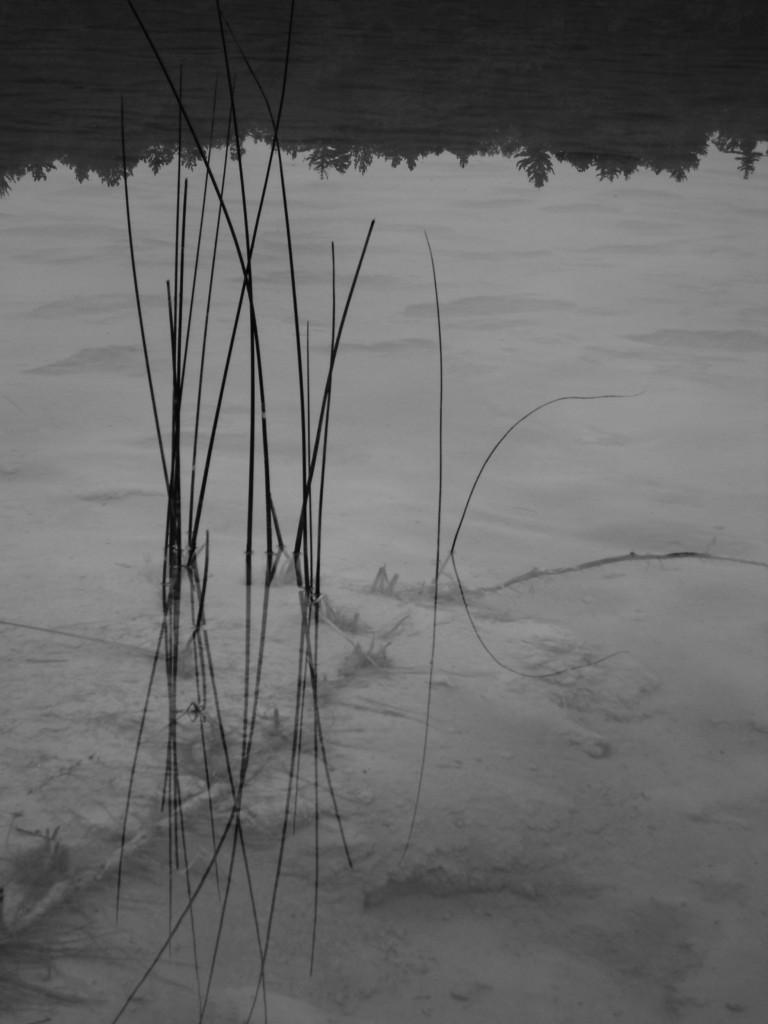What is the primary element visible in the image? There is water in the image. What can be seen in the water due to the reflection? The reflection of trees is visible in the water. What type of objects are present in the water? There are black colored objects in the water. Can you see any examples of icicles hanging from the trees in the image? There are no icicles visible in the image; it features water with the reflection of trees and black colored objects. Is there a coast visible in the image? There is no coast visible in the image; it features water with the reflection of trees and black colored objects. 